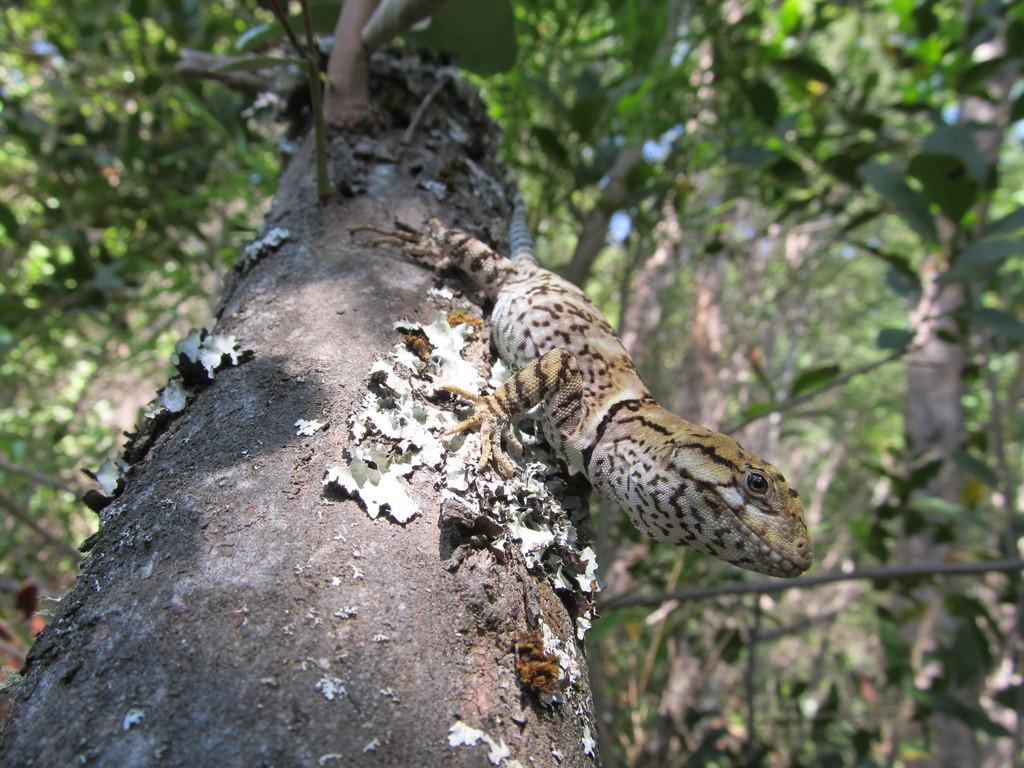Please provide a concise description of this image. In the picture I can see a Blue-tongued skink on a tree trunk and there are few other trees in the background. 